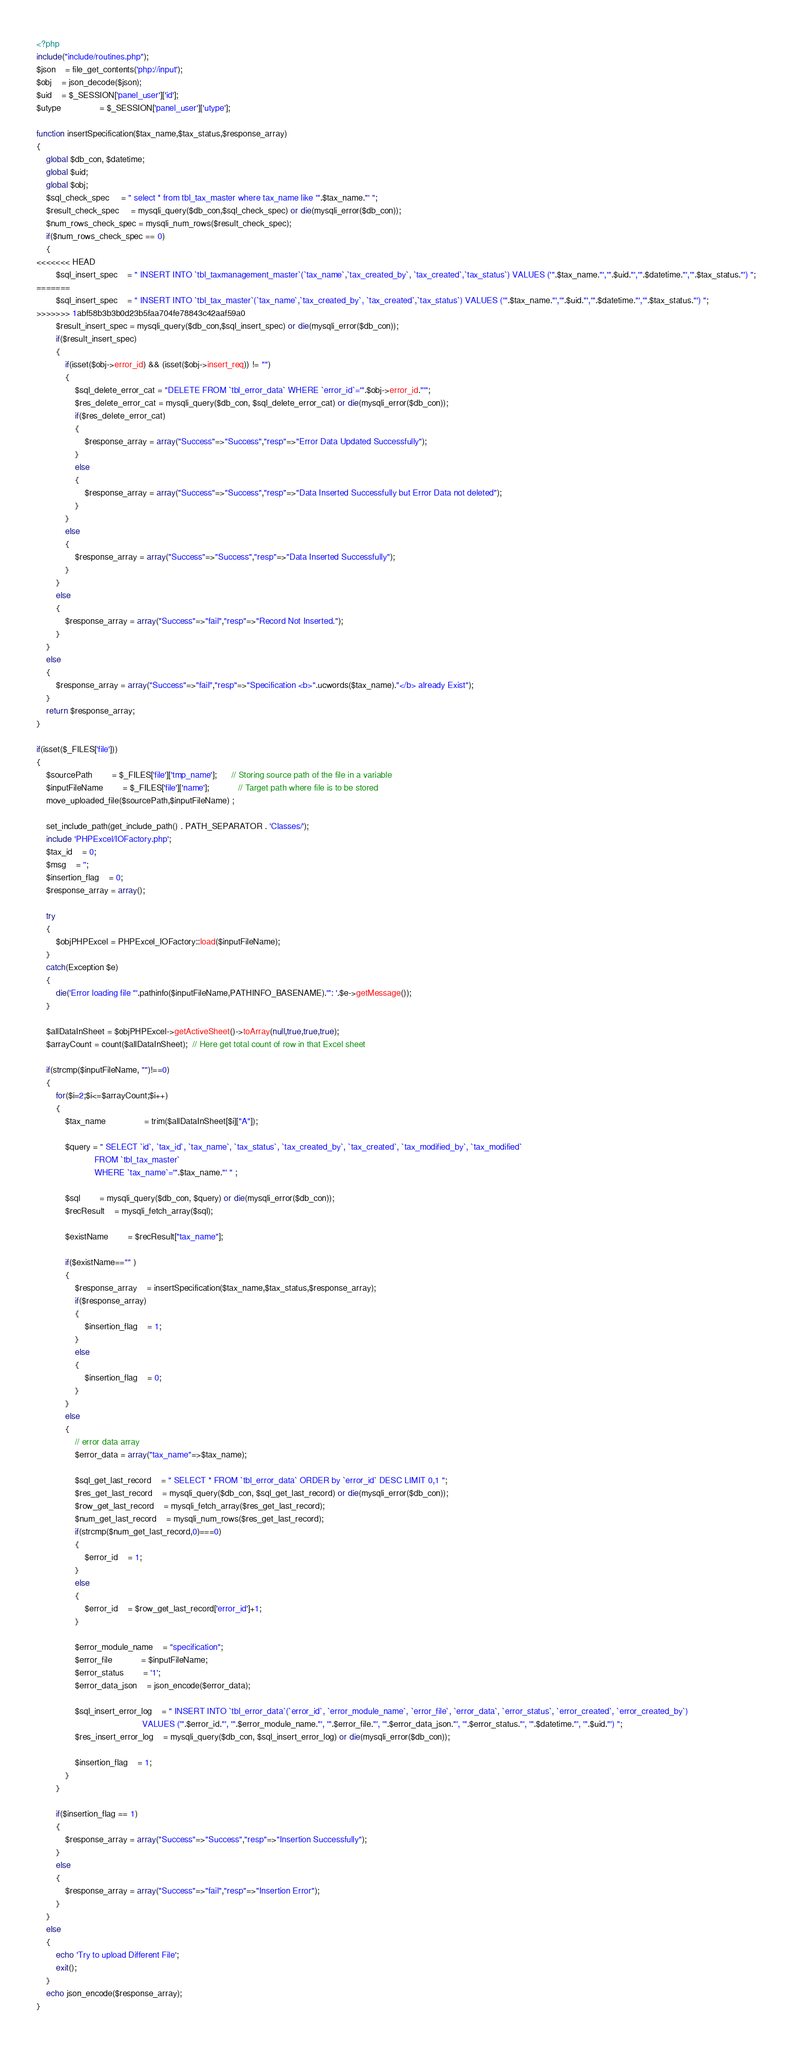Convert code to text. <code><loc_0><loc_0><loc_500><loc_500><_PHP_><?php
include("include/routines.php");
$json 	= file_get_contents('php://input');
$obj 	= json_decode($json);
$uid	= $_SESSION['panel_user']['id'];
$utype				= $_SESSION['panel_user']['utype'];

function insertSpecification($tax_name,$tax_status,$response_array)
{
	global $db_con, $datetime;
	global $uid;
	global $obj;
	$sql_check_spec 	 = " select * from tbl_tax_master where tax_name like '".$tax_name."' "; 
	$result_check_spec 	 = mysqli_query($db_con,$sql_check_spec) or die(mysqli_error($db_con));
	$num_rows_check_spec = mysqli_num_rows($result_check_spec);
	if($num_rows_check_spec == 0)
	{
<<<<<<< HEAD
		$sql_insert_spec 	= " INSERT INTO `tbl_taxmanagement_master`(`tax_name`,`tax_created_by`, `tax_created`,`tax_status`) VALUES ('".$tax_name."','".$uid."','".$datetime."','".$tax_status."') ";
=======
		$sql_insert_spec 	= " INSERT INTO `tbl_tax_master`(`tax_name`,`tax_created_by`, `tax_created`,`tax_status`) VALUES ('".$tax_name."','".$uid."','".$datetime."','".$tax_status."') ";
>>>>>>> 1abf58b3b3b0d23b5faa704fe78843c42aaf59a0
		$result_insert_spec = mysqli_query($db_con,$sql_insert_spec) or die(mysqli_error($db_con));
		if($result_insert_spec)
		{
			if(isset($obj->error_id) && (isset($obj->insert_req)) != "")			
			{
				$sql_delete_error_cat = "DELETE FROM `tbl_error_data` WHERE `error_id`='".$obj->error_id."'";
				$res_delete_error_cat = mysqli_query($db_con, $sql_delete_error_cat) or die(mysqli_error($db_con));				
				if($res_delete_error_cat)
				{
					$response_array = array("Success"=>"Success","resp"=>"Error Data Updated Successfully");
				}
				else
				{
					$response_array = array("Success"=>"Success","resp"=>"Data Inserted Successfully but Error Data not deleted");												
				}
			}
			else
			{
				$response_array = array("Success"=>"Success","resp"=>"Data Inserted Successfully");					
			}				
		}
		else
		{
			$response_array = array("Success"=>"fail","resp"=>"Record Not Inserted.");					
		}			
	}
	else
	{
		$response_array = array("Success"=>"fail","resp"=>"Specification <b>".ucwords($tax_name)."</b> already Exist");
	}	
	return $response_array;
}

if(isset($_FILES['file']))
{
	$sourcePath 		= $_FILES['file']['tmp_name'];      // Storing source path of the file in a variable
	$inputFileName 		= $_FILES['file']['name']; 			// Target path where file is to be stored
	move_uploaded_file($sourcePath,$inputFileName) ;
	
	set_include_path(get_include_path() . PATH_SEPARATOR . 'Classes/');
	include 'PHPExcel/IOFactory.php';
	$tax_id 	= 0;
	$msg	= '';
	$insertion_flag	= 0;
	$response_array = array();
	
	try 
	{
		$objPHPExcel = PHPExcel_IOFactory::load($inputFileName);
	} 
	catch(Exception $e) 
	{
		die('Error loading file "'.pathinfo($inputFileName,PATHINFO_BASENAME).'": '.$e->getMessage());
	}
	
	$allDataInSheet = $objPHPExcel->getActiveSheet()->toArray(null,true,true,true);
	$arrayCount = count($allDataInSheet);  // Here get total count of row in that Excel sheet
	
	if(strcmp($inputFileName, "")!==0)
	{
		for($i=2;$i<=$arrayCount;$i++)
		{
			$tax_name 				= trim($allDataInSheet[$i]["A"]);
			
			$query = " SELECT `id`, `tax_id`, `tax_name`, `tax_status`, `tax_created_by`, `tax_created`, `tax_modified_by`, `tax_modified` 
						FROM `tbl_tax_master` 
						WHERE `tax_name`='".$tax_name."' " ;
							
			$sql 		= mysqli_query($db_con, $query) or die(mysqli_error($db_con));
			$recResult 	= mysqli_fetch_array($sql);
			
			$existName 		= $recResult["tax_name"];
			
			if($existName=="" )
			{
				$response_array 	= insertSpecification($tax_name,$tax_status,$response_array);
				if($response_array)
				{
					$insertion_flag	= 1;	
				}
				else
				{
					$insertion_flag	= 0;	
				}
			}
			else
			{
				// error data array
				$error_data = array("tax_name"=>$tax_name);	
				
				$sql_get_last_record	= " SELECT * FROM `tbl_error_data` ORDER by `error_id` DESC LIMIT 0,1 ";
				$res_get_last_record	= mysqli_query($db_con, $sql_get_last_record) or die(mysqli_error($db_con));
				$row_get_last_record	= mysqli_fetch_array($res_get_last_record);
				$num_get_last_record	= mysqli_num_rows($res_get_last_record);
				if(strcmp($num_get_last_record,0)===0)
				{
					$error_id	= 1;
				}
				else
				{
					$error_id	= $row_get_last_record['error_id']+1;
				}
				
				$error_module_name	= "specification";
				$error_file			= $inputFileName;
				$error_status		= '1';
				$error_data_json	= json_encode($error_data);
				
				$sql_insert_error_log	= " INSERT INTO `tbl_error_data`(`error_id`, `error_module_name`, `error_file`, `error_data`, `error_status`, `error_created`, `error_created_by`) 
											VALUES ('".$error_id."', '".$error_module_name."', '".$error_file."', '".$error_data_json."', '".$error_status."', '".$datetime."', '".$uid."') ";
				$res_insert_error_log 	= mysqli_query($db_con, $sql_insert_error_log) or die(mysqli_error($db_con));
				
				$insertion_flag	= 1;
			}
		}
		
		if($insertion_flag == 1)
		{
			$response_array = array("Success"=>"Success","resp"=>"Insertion Successfully");	
		}
		else
		{
			$response_array = array("Success"=>"fail","resp"=>"Insertion Error");			
		}
	}
	else
	{
		echo 'Try to upload Different File';
		exit();
	}
	echo json_encode($response_array);
}
</code> 